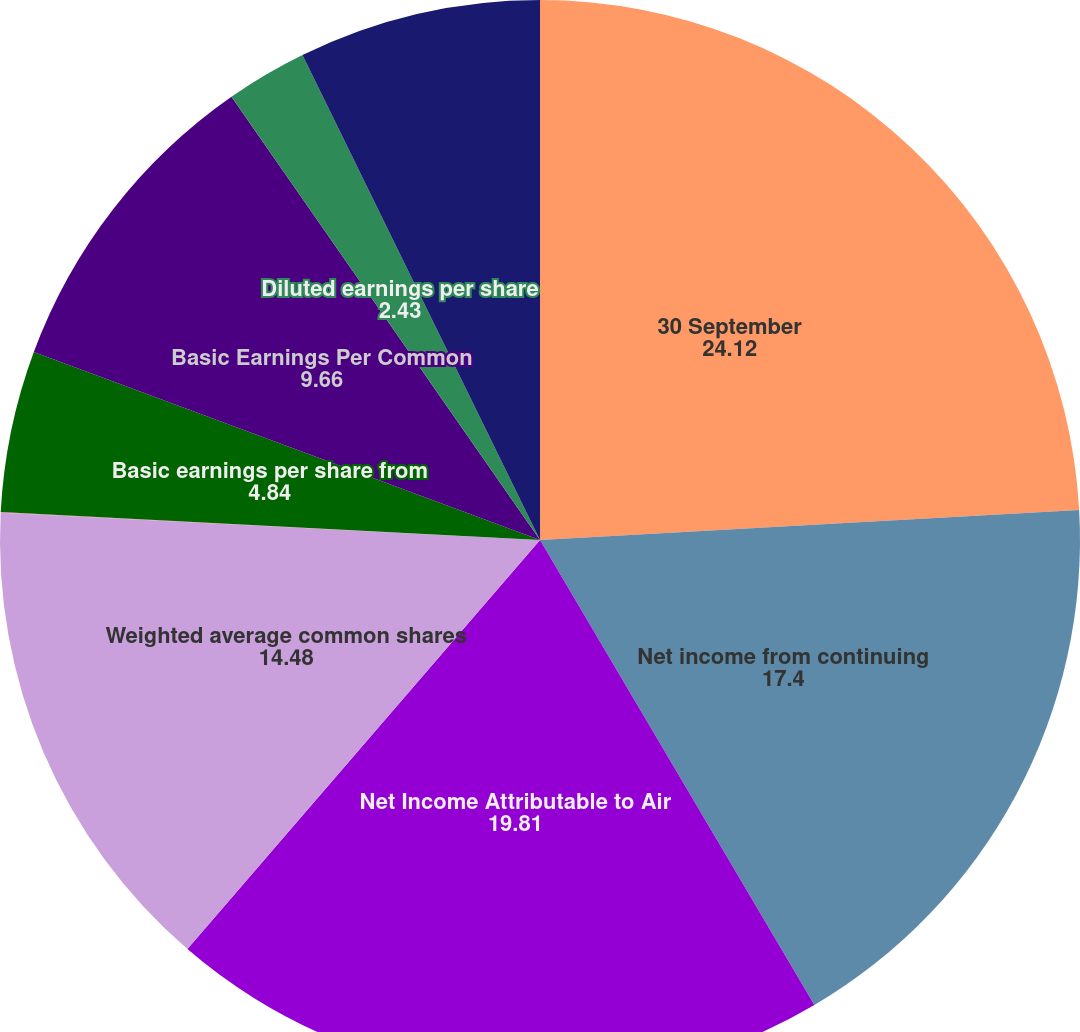Convert chart. <chart><loc_0><loc_0><loc_500><loc_500><pie_chart><fcel>30 September<fcel>Net income from continuing<fcel>Net Income Attributable to Air<fcel>Weighted average common shares<fcel>Employee stock option and<fcel>Basic earnings per share from<fcel>Basic Earnings Per Common<fcel>Diluted earnings per share<fcel>Diluted Earnings Per Common<nl><fcel>24.12%<fcel>17.4%<fcel>19.81%<fcel>14.48%<fcel>0.02%<fcel>4.84%<fcel>9.66%<fcel>2.43%<fcel>7.25%<nl></chart> 